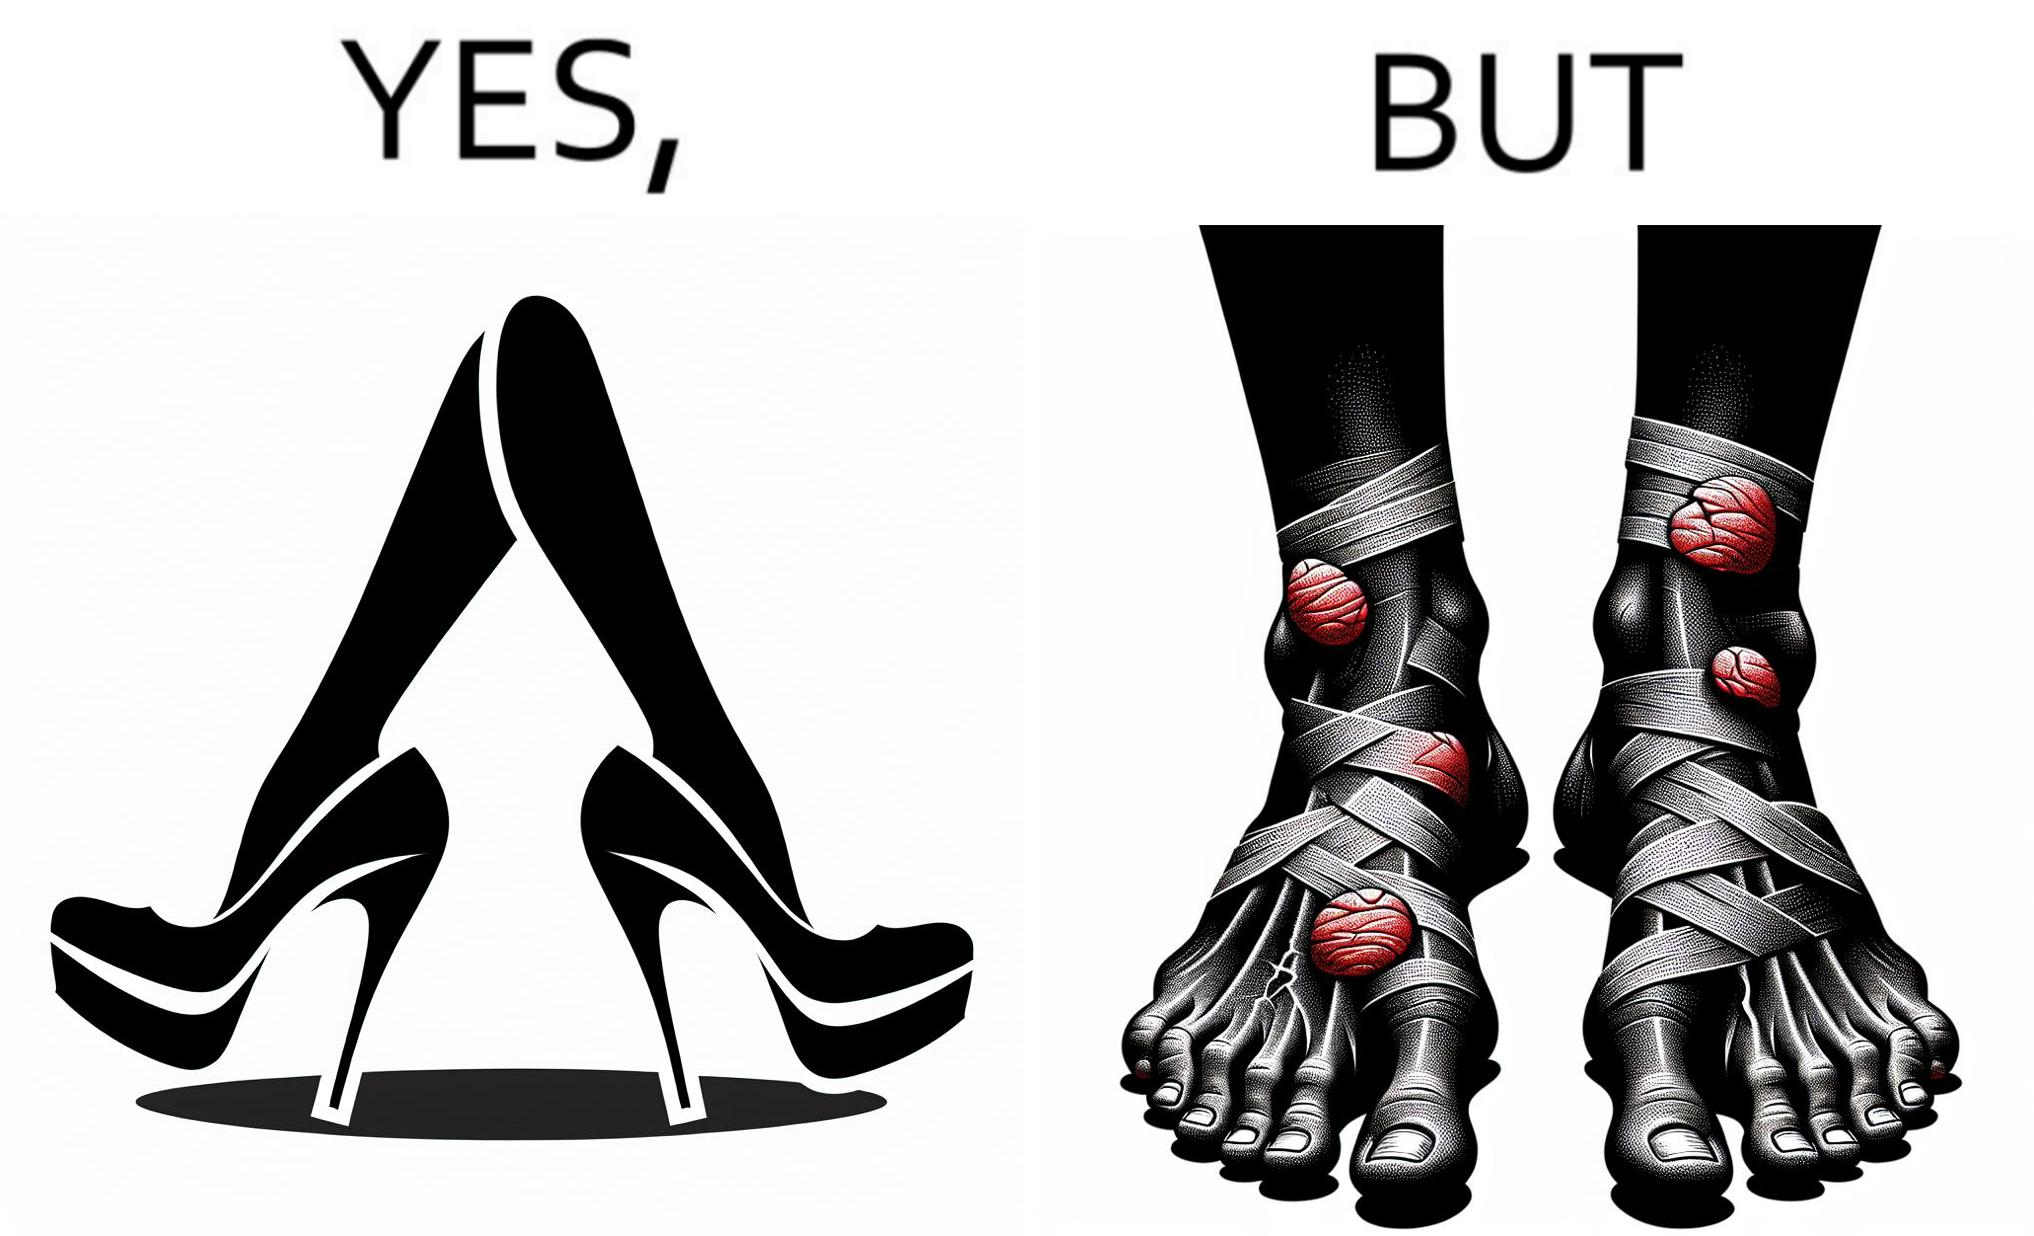Describe what you see in this image. The images are funny since they show how the prettiest footwears like high heels, end up causing a lot of physical discomfort to the user, all in the name fashion 